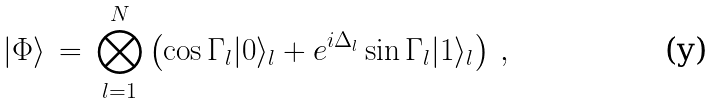<formula> <loc_0><loc_0><loc_500><loc_500>| \Phi \rangle \, = \, \bigotimes _ { l = 1 } ^ { N } \left ( \cos \Gamma _ { l } | 0 \rangle _ { l } + e ^ { i \Delta _ { l } } \sin \Gamma _ { l } | 1 \rangle _ { l } \right ) \, ,</formula> 